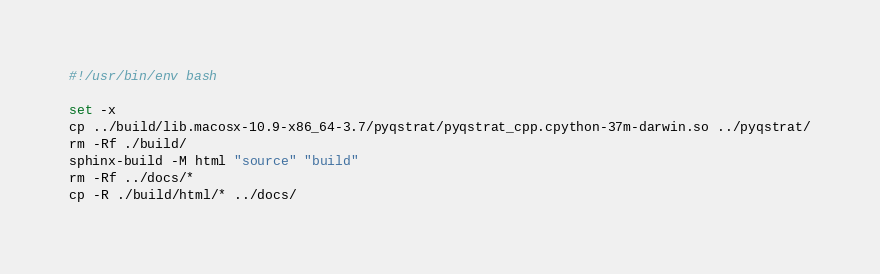<code> <loc_0><loc_0><loc_500><loc_500><_Bash_>#!/usr/bin/env bash

set -x
cp ../build/lib.macosx-10.9-x86_64-3.7/pyqstrat/pyqstrat_cpp.cpython-37m-darwin.so ../pyqstrat/
rm -Rf ./build/
sphinx-build -M html "source" "build"
rm -Rf ../docs/*
cp -R ./build/html/* ../docs/
</code> 